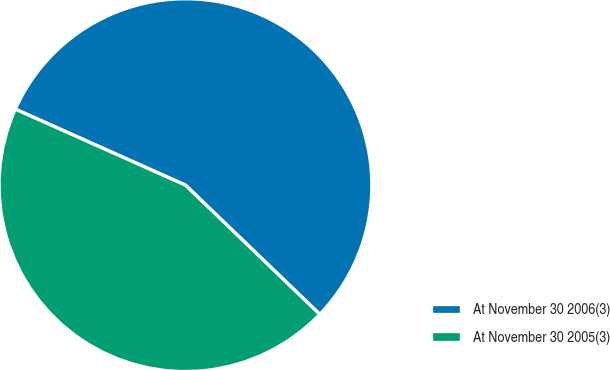<chart> <loc_0><loc_0><loc_500><loc_500><pie_chart><fcel>At November 30 2006(3)<fcel>At November 30 2005(3)<nl><fcel>55.5%<fcel>44.5%<nl></chart> 